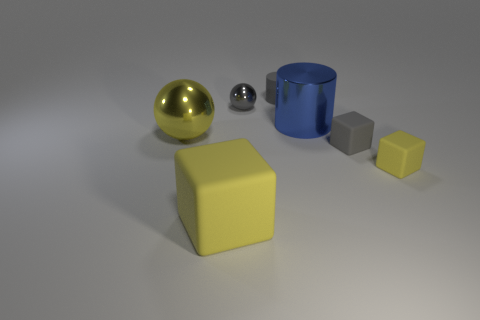There is a yellow matte cube that is to the left of the big blue thing; is its size the same as the gray matte thing in front of the yellow shiny sphere?
Offer a very short reply. No. There is a thing behind the tiny gray metallic ball; what is its shape?
Keep it short and to the point. Cylinder. There is a tiny yellow object that is in front of the rubber object that is behind the tiny gray block; what is it made of?
Make the answer very short. Rubber. Is there another large cylinder that has the same color as the big metallic cylinder?
Offer a terse response. No. Do the gray metal thing and the yellow shiny sphere that is in front of the gray cylinder have the same size?
Provide a succinct answer. No. How many large rubber cubes are behind the gray rubber object that is in front of the small metallic sphere that is right of the big yellow ball?
Your answer should be very brief. 0. There is a gray ball; what number of gray matte objects are behind it?
Make the answer very short. 1. There is a large metallic object right of the large yellow thing that is to the left of the big yellow block; what color is it?
Provide a succinct answer. Blue. What number of other things are made of the same material as the big cube?
Give a very brief answer. 3. Are there an equal number of yellow things on the left side of the rubber cylinder and gray shiny spheres?
Keep it short and to the point. No. 